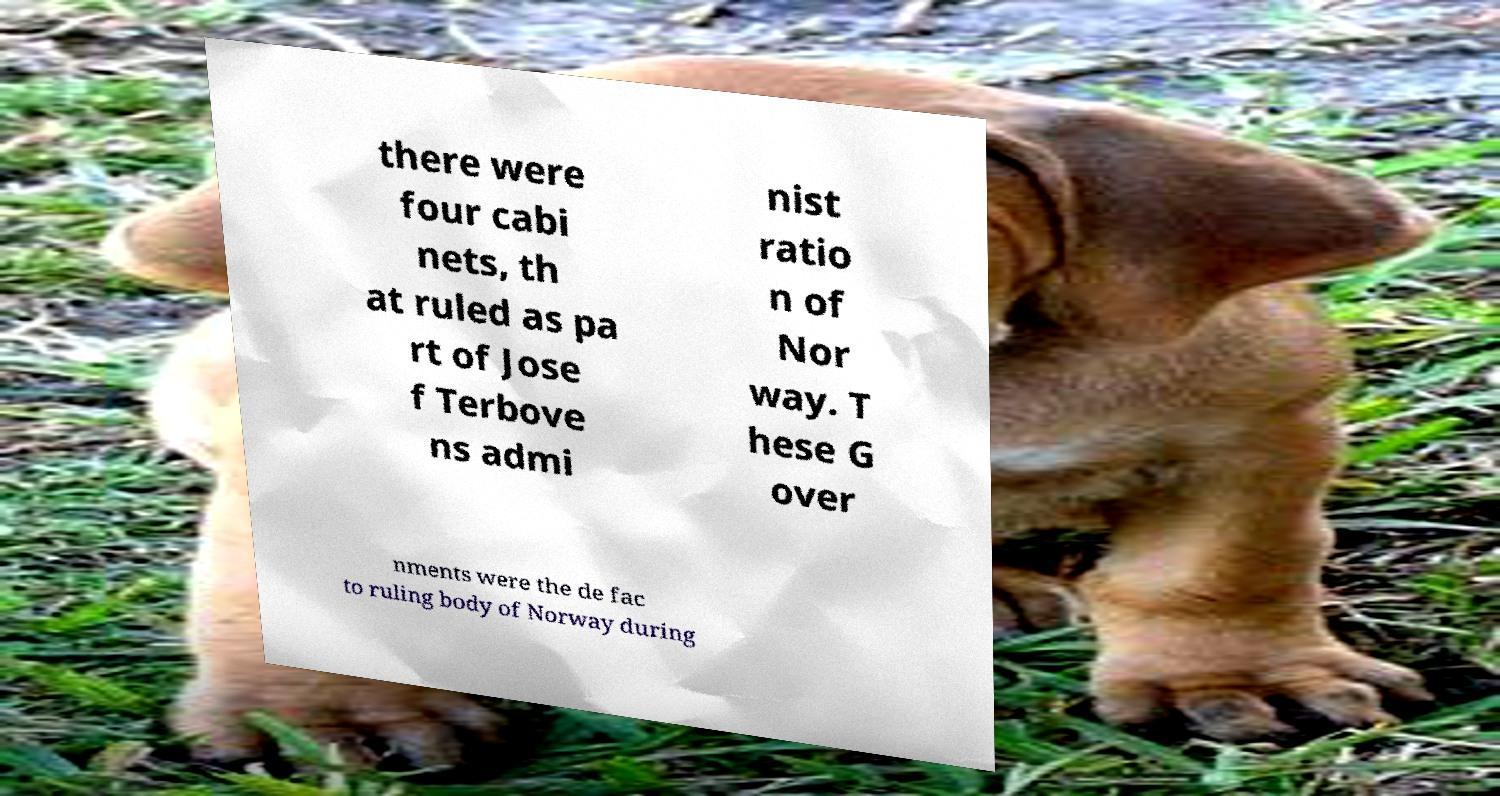Please read and relay the text visible in this image. What does it say? there were four cabi nets, th at ruled as pa rt of Jose f Terbove ns admi nist ratio n of Nor way. T hese G over nments were the de fac to ruling body of Norway during 